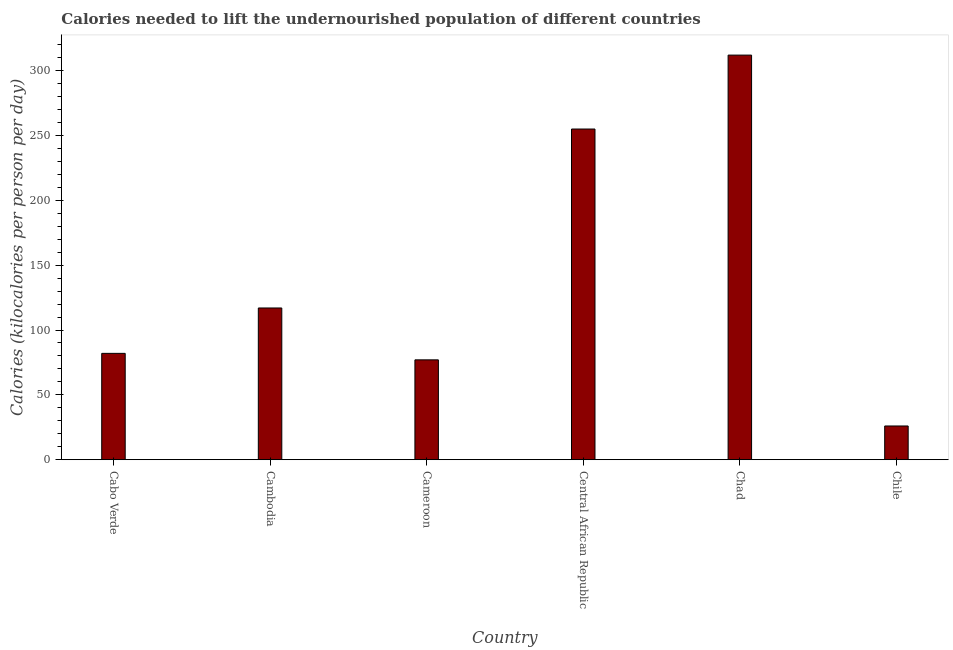Does the graph contain any zero values?
Your response must be concise. No. Does the graph contain grids?
Give a very brief answer. No. What is the title of the graph?
Make the answer very short. Calories needed to lift the undernourished population of different countries. What is the label or title of the Y-axis?
Offer a terse response. Calories (kilocalories per person per day). What is the depth of food deficit in Central African Republic?
Offer a terse response. 255. Across all countries, what is the maximum depth of food deficit?
Ensure brevity in your answer.  312. In which country was the depth of food deficit maximum?
Ensure brevity in your answer.  Chad. In which country was the depth of food deficit minimum?
Provide a short and direct response. Chile. What is the sum of the depth of food deficit?
Provide a short and direct response. 869. What is the difference between the depth of food deficit in Cambodia and Cameroon?
Offer a terse response. 40. What is the average depth of food deficit per country?
Provide a succinct answer. 144.83. What is the median depth of food deficit?
Provide a succinct answer. 99.5. What is the ratio of the depth of food deficit in Cambodia to that in Central African Republic?
Your answer should be compact. 0.46. Is the difference between the depth of food deficit in Cabo Verde and Chad greater than the difference between any two countries?
Offer a very short reply. No. What is the difference between the highest and the second highest depth of food deficit?
Make the answer very short. 57. What is the difference between the highest and the lowest depth of food deficit?
Provide a short and direct response. 286. How many bars are there?
Offer a very short reply. 6. Are all the bars in the graph horizontal?
Give a very brief answer. No. How many countries are there in the graph?
Offer a very short reply. 6. What is the difference between two consecutive major ticks on the Y-axis?
Your answer should be very brief. 50. Are the values on the major ticks of Y-axis written in scientific E-notation?
Provide a succinct answer. No. What is the Calories (kilocalories per person per day) of Cabo Verde?
Give a very brief answer. 82. What is the Calories (kilocalories per person per day) in Cambodia?
Your response must be concise. 117. What is the Calories (kilocalories per person per day) of Central African Republic?
Offer a terse response. 255. What is the Calories (kilocalories per person per day) of Chad?
Provide a short and direct response. 312. What is the Calories (kilocalories per person per day) of Chile?
Provide a succinct answer. 26. What is the difference between the Calories (kilocalories per person per day) in Cabo Verde and Cambodia?
Provide a short and direct response. -35. What is the difference between the Calories (kilocalories per person per day) in Cabo Verde and Cameroon?
Offer a very short reply. 5. What is the difference between the Calories (kilocalories per person per day) in Cabo Verde and Central African Republic?
Offer a terse response. -173. What is the difference between the Calories (kilocalories per person per day) in Cabo Verde and Chad?
Provide a short and direct response. -230. What is the difference between the Calories (kilocalories per person per day) in Cabo Verde and Chile?
Ensure brevity in your answer.  56. What is the difference between the Calories (kilocalories per person per day) in Cambodia and Central African Republic?
Make the answer very short. -138. What is the difference between the Calories (kilocalories per person per day) in Cambodia and Chad?
Your response must be concise. -195. What is the difference between the Calories (kilocalories per person per day) in Cambodia and Chile?
Provide a short and direct response. 91. What is the difference between the Calories (kilocalories per person per day) in Cameroon and Central African Republic?
Offer a very short reply. -178. What is the difference between the Calories (kilocalories per person per day) in Cameroon and Chad?
Ensure brevity in your answer.  -235. What is the difference between the Calories (kilocalories per person per day) in Cameroon and Chile?
Give a very brief answer. 51. What is the difference between the Calories (kilocalories per person per day) in Central African Republic and Chad?
Your answer should be very brief. -57. What is the difference between the Calories (kilocalories per person per day) in Central African Republic and Chile?
Ensure brevity in your answer.  229. What is the difference between the Calories (kilocalories per person per day) in Chad and Chile?
Ensure brevity in your answer.  286. What is the ratio of the Calories (kilocalories per person per day) in Cabo Verde to that in Cambodia?
Ensure brevity in your answer.  0.7. What is the ratio of the Calories (kilocalories per person per day) in Cabo Verde to that in Cameroon?
Offer a very short reply. 1.06. What is the ratio of the Calories (kilocalories per person per day) in Cabo Verde to that in Central African Republic?
Make the answer very short. 0.32. What is the ratio of the Calories (kilocalories per person per day) in Cabo Verde to that in Chad?
Ensure brevity in your answer.  0.26. What is the ratio of the Calories (kilocalories per person per day) in Cabo Verde to that in Chile?
Keep it short and to the point. 3.15. What is the ratio of the Calories (kilocalories per person per day) in Cambodia to that in Cameroon?
Offer a terse response. 1.52. What is the ratio of the Calories (kilocalories per person per day) in Cambodia to that in Central African Republic?
Offer a very short reply. 0.46. What is the ratio of the Calories (kilocalories per person per day) in Cambodia to that in Chile?
Provide a short and direct response. 4.5. What is the ratio of the Calories (kilocalories per person per day) in Cameroon to that in Central African Republic?
Make the answer very short. 0.3. What is the ratio of the Calories (kilocalories per person per day) in Cameroon to that in Chad?
Give a very brief answer. 0.25. What is the ratio of the Calories (kilocalories per person per day) in Cameroon to that in Chile?
Make the answer very short. 2.96. What is the ratio of the Calories (kilocalories per person per day) in Central African Republic to that in Chad?
Keep it short and to the point. 0.82. What is the ratio of the Calories (kilocalories per person per day) in Central African Republic to that in Chile?
Make the answer very short. 9.81. 